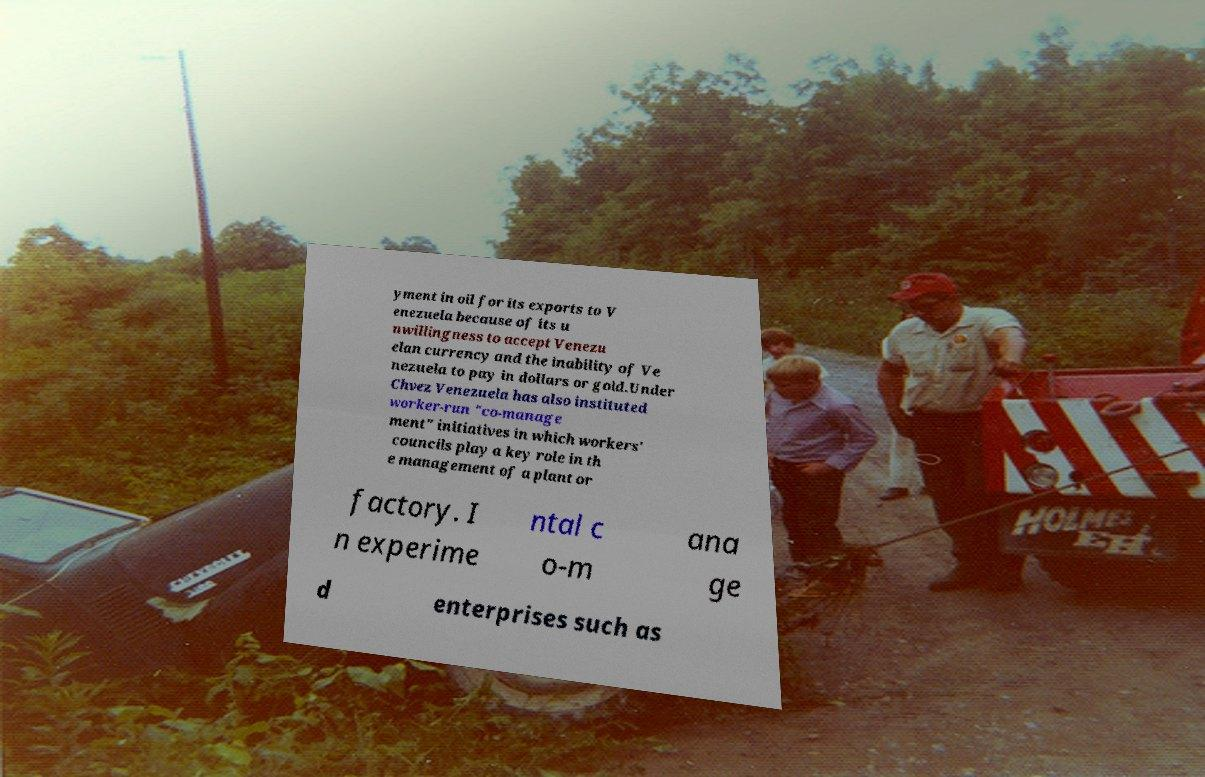Please identify and transcribe the text found in this image. yment in oil for its exports to V enezuela because of its u nwillingness to accept Venezu elan currency and the inability of Ve nezuela to pay in dollars or gold.Under Chvez Venezuela has also instituted worker-run "co-manage ment" initiatives in which workers' councils play a key role in th e management of a plant or factory. I n experime ntal c o-m ana ge d enterprises such as 